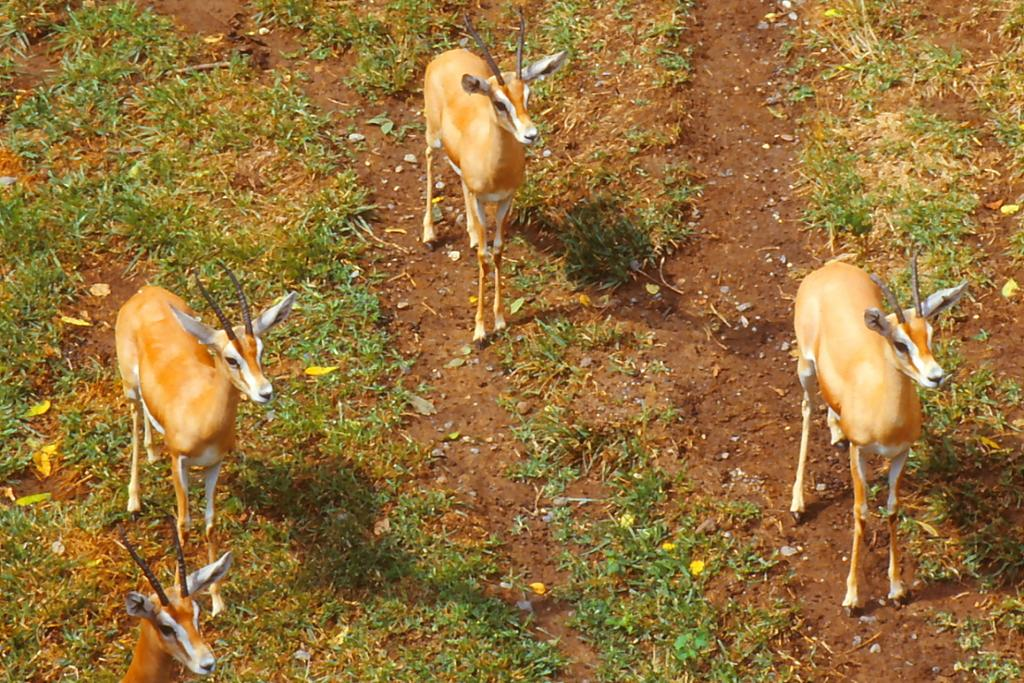What is the main subject of the image? The main subject of the image is a herd. Where is the herd located in the image? The herd is on the ground. What type of vegetation can be seen in the image? There is grass visible in the image. What type of knowledge can be gained from the yam in the image? There is no yam present in the image, so no knowledge can be gained from it. 